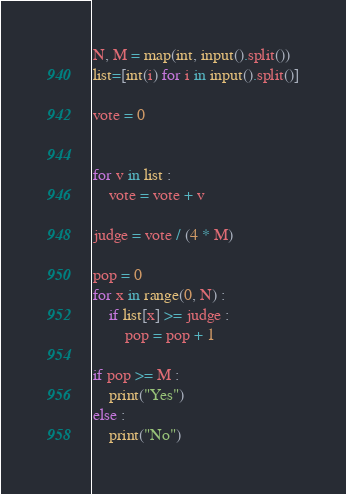Convert code to text. <code><loc_0><loc_0><loc_500><loc_500><_Python_>N, M = map(int, input().split())
list=[int(i) for i in input().split()]

vote = 0


for v in list :
    vote = vote + v

judge = vote / (4 * M)

pop = 0
for x in range(0, N) :
    if list[x] >= judge :
        pop = pop + 1

if pop >= M :
    print("Yes")
else :
    print("No")

</code> 